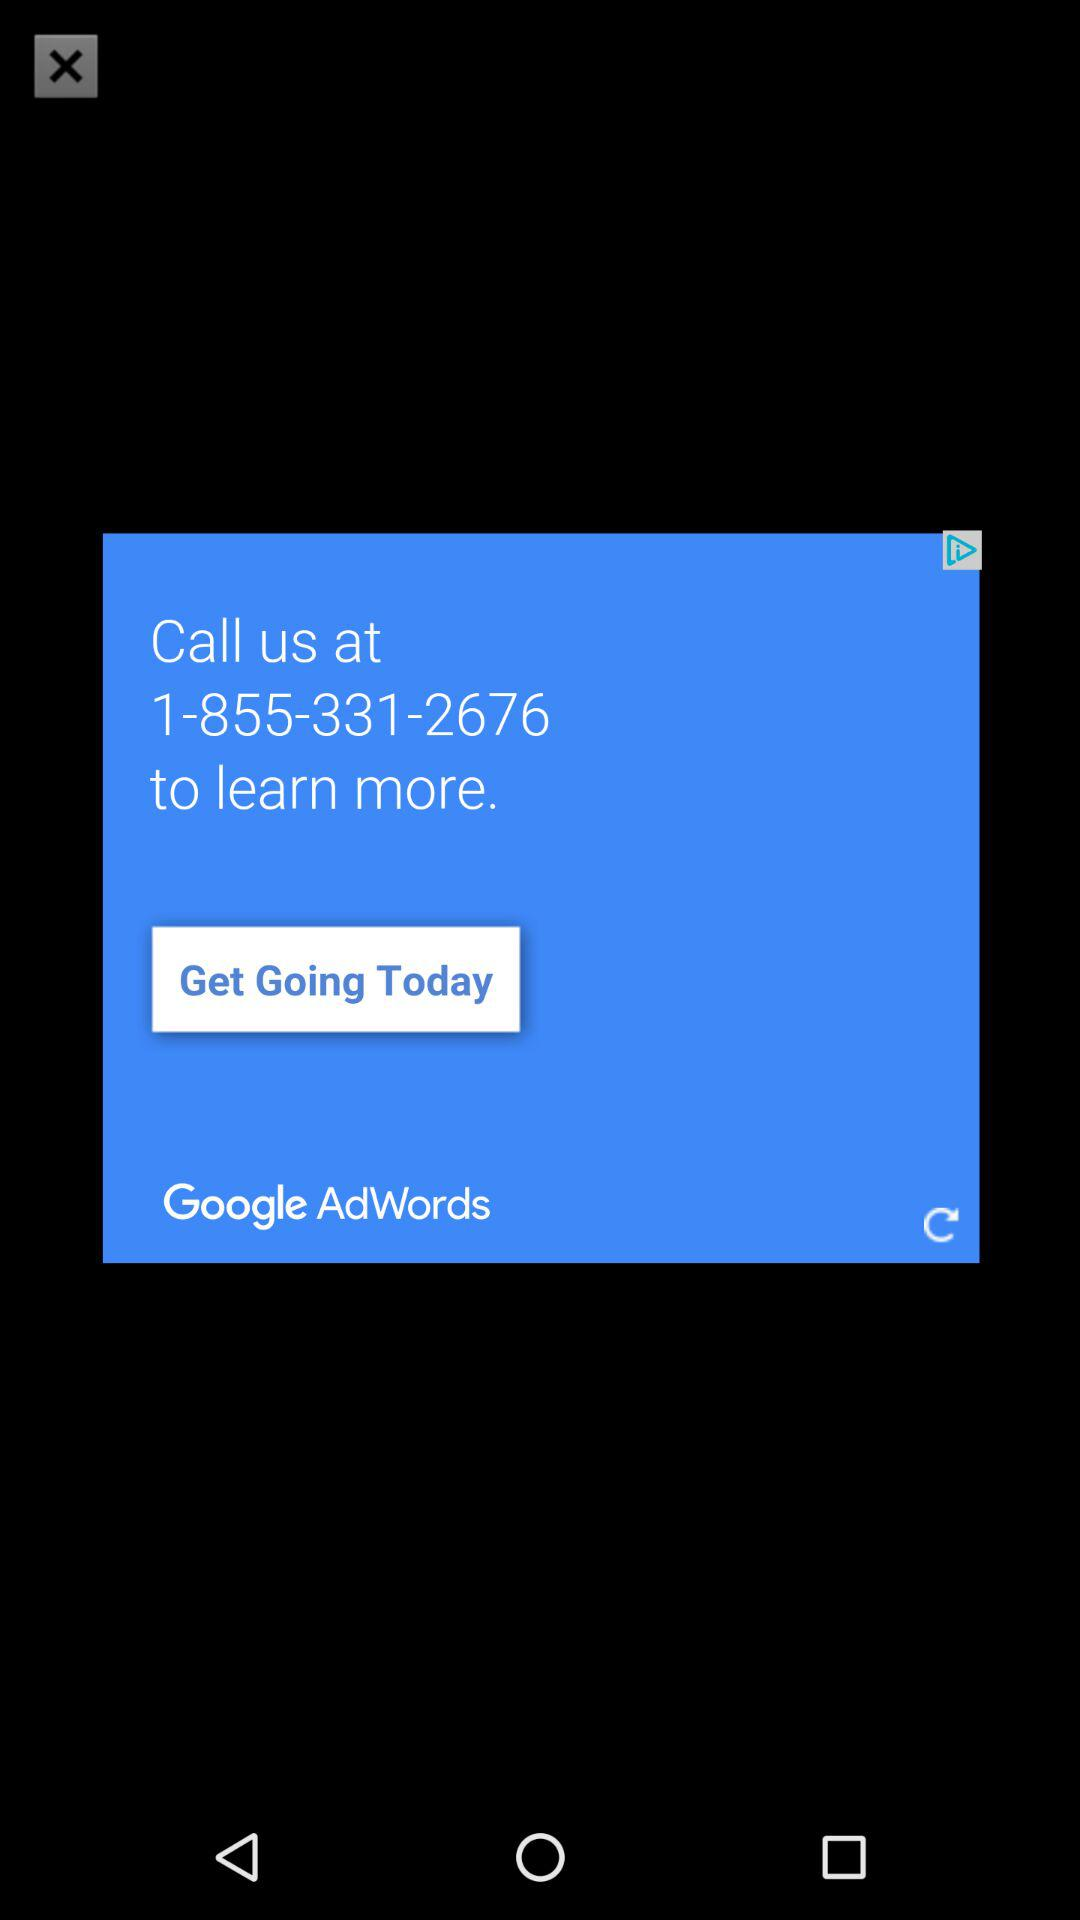What is the number? The number is 1-855-331-2676. 